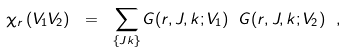Convert formula to latex. <formula><loc_0><loc_0><loc_500><loc_500>\chi _ { r } \left ( V _ { 1 } V _ { 2 } \right ) \ = \ \sum _ { \{ J k \} } G ( r , J , k ; V _ { 1 } ) \ G ( r , J , k ; V _ { 2 } ) \ ,</formula> 